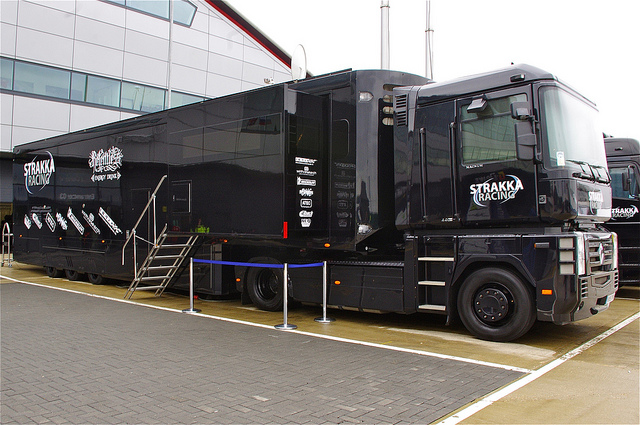Please transcribe the text information in this image. STRAKK RACING STRAKKA 